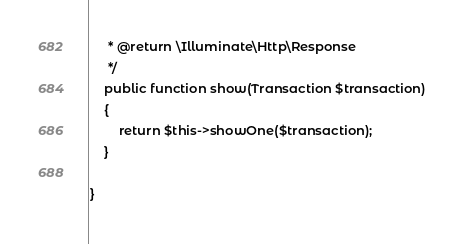Convert code to text. <code><loc_0><loc_0><loc_500><loc_500><_PHP_>     * @return \Illuminate\Http\Response
     */
    public function show(Transaction $transaction)
    {
        return $this->showOne($transaction);
    }

}
</code> 